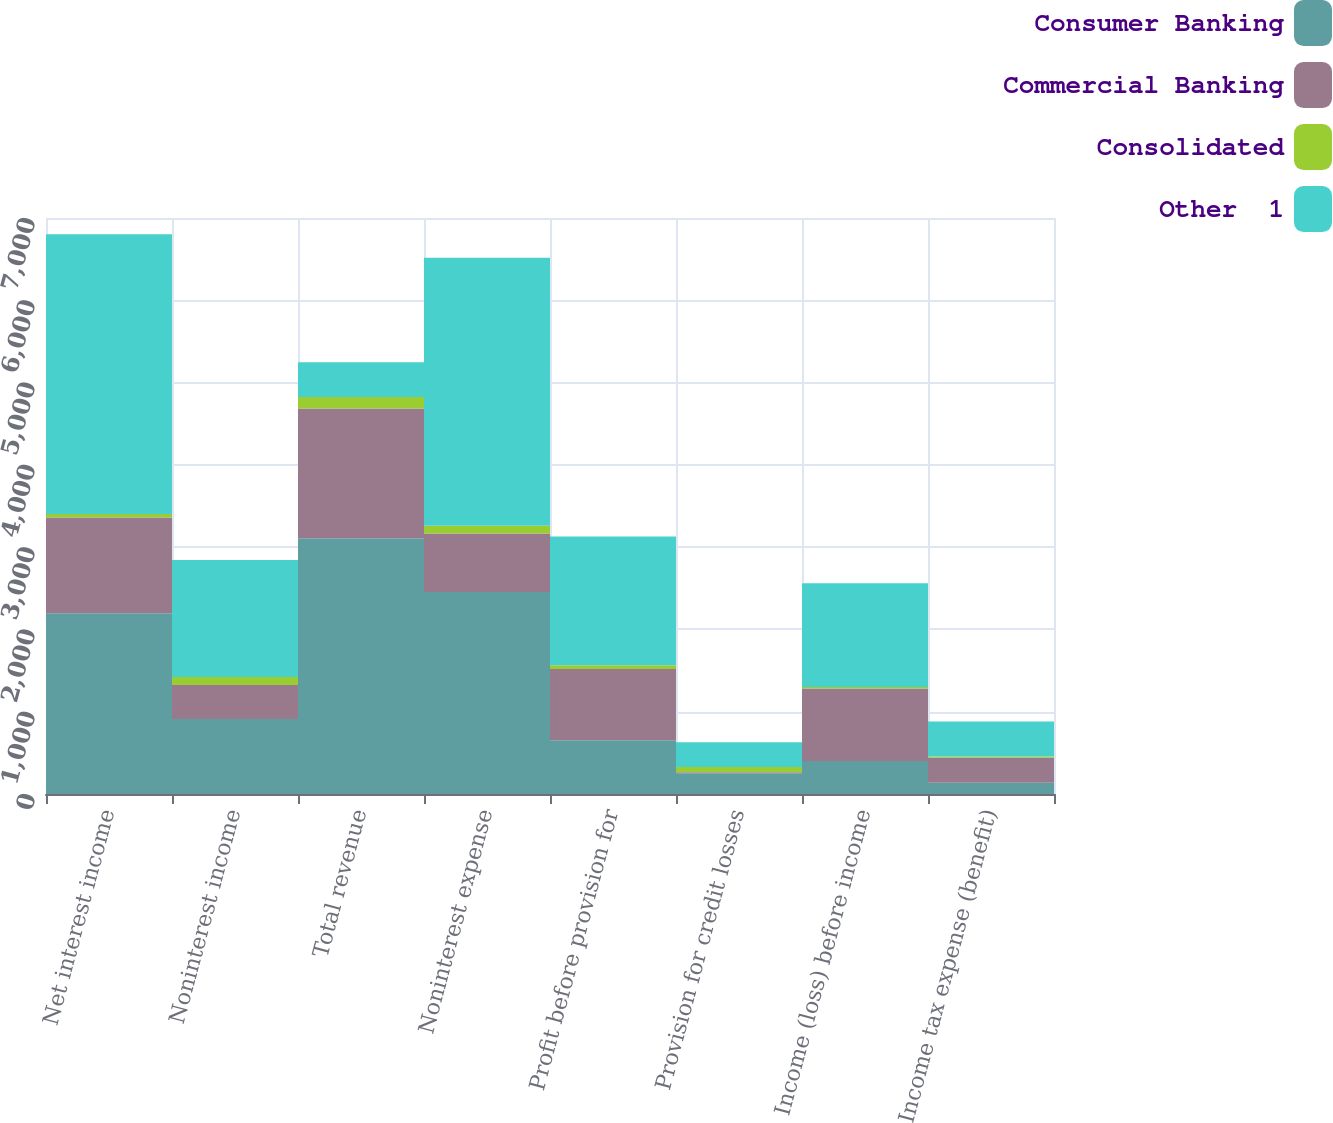Convert chart to OTSL. <chart><loc_0><loc_0><loc_500><loc_500><stacked_bar_chart><ecel><fcel>Net interest income<fcel>Noninterest income<fcel>Total revenue<fcel>Noninterest expense<fcel>Profit before provision for<fcel>Provision for credit losses<fcel>Income (loss) before income<fcel>Income tax expense (benefit)<nl><fcel>Consumer Banking<fcel>2198<fcel>910<fcel>3108<fcel>2456<fcel>652<fcel>252<fcel>400<fcel>138<nl><fcel>Commercial Banking<fcel>1162<fcel>415<fcel>1577<fcel>709<fcel>868<fcel>13<fcel>881<fcel>302<nl><fcel>Consolidated<fcel>42<fcel>97<fcel>139<fcel>94<fcel>45<fcel>63<fcel>18<fcel>17<nl><fcel>Other  1<fcel>3402<fcel>1422<fcel>423<fcel>3259<fcel>1565<fcel>302<fcel>1263<fcel>423<nl></chart> 